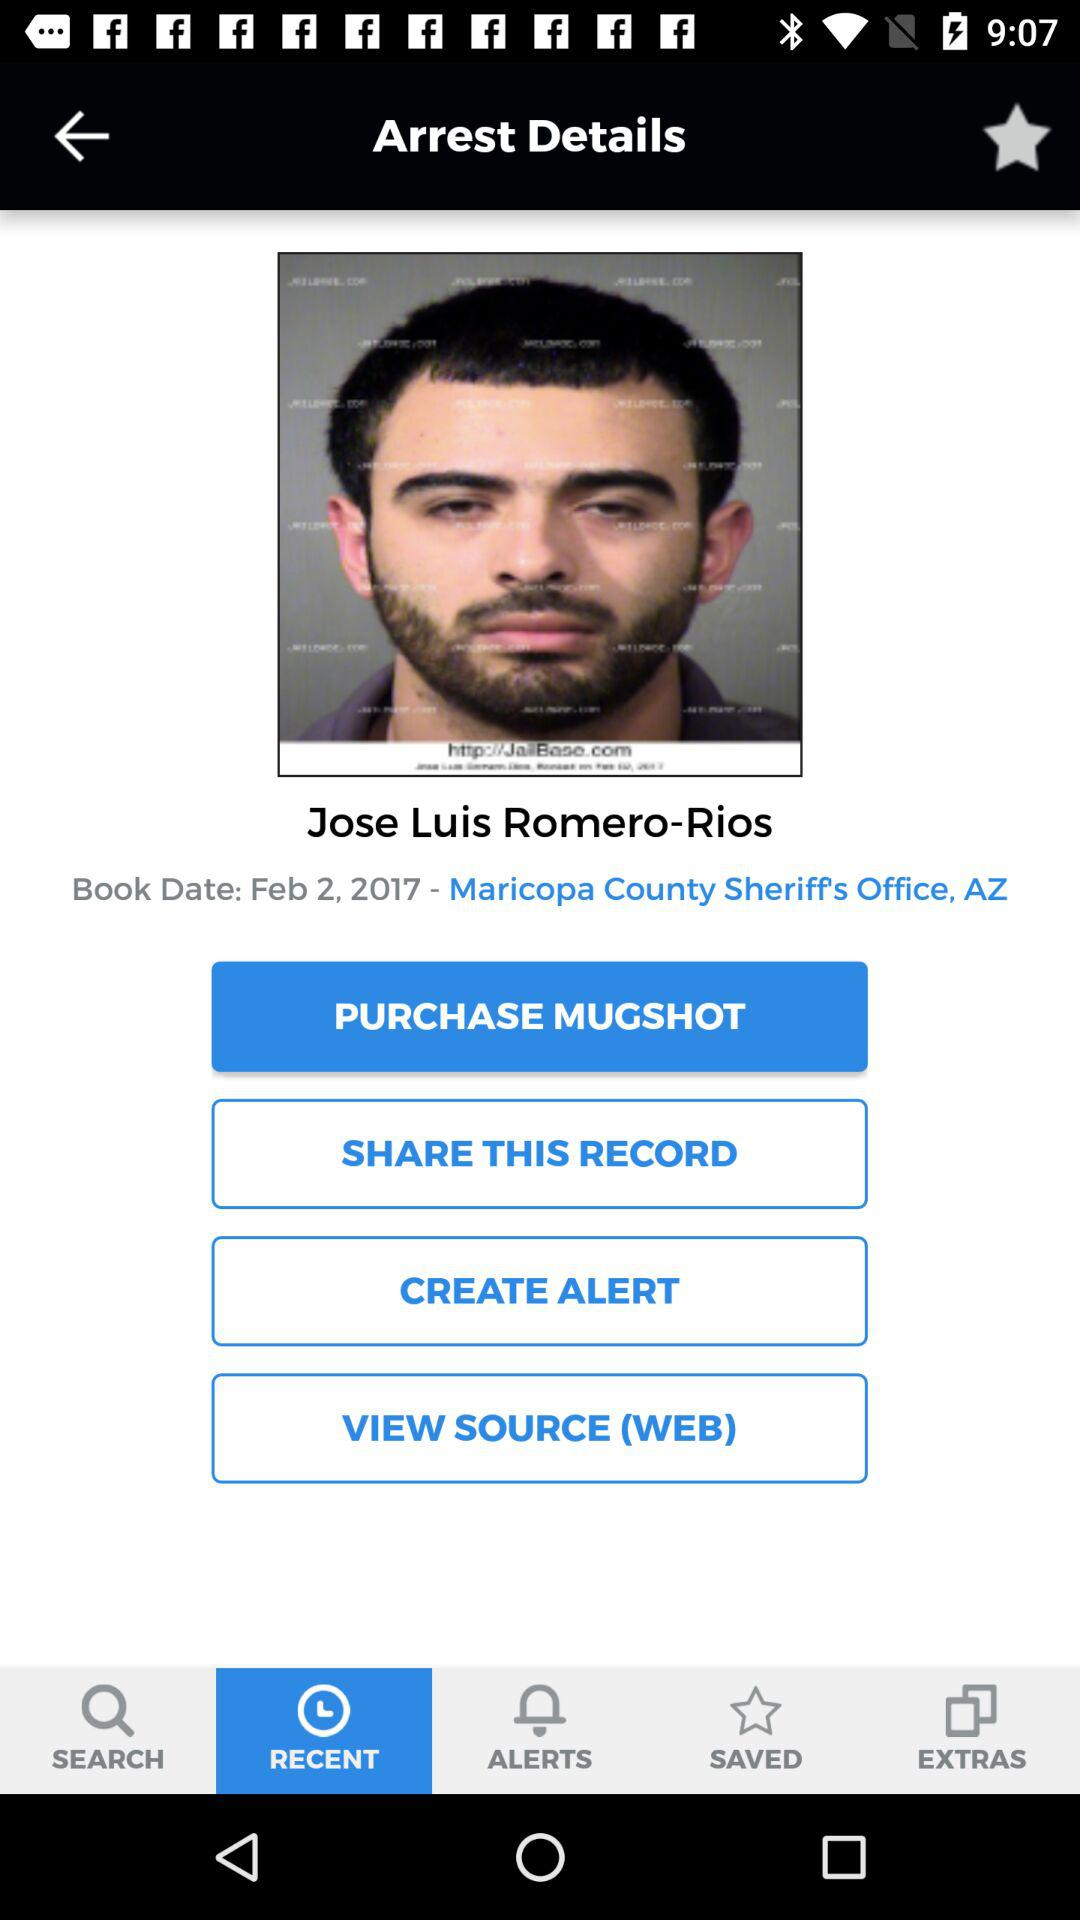What is the given name? The given name is Jose Luis Romero-Rios. 